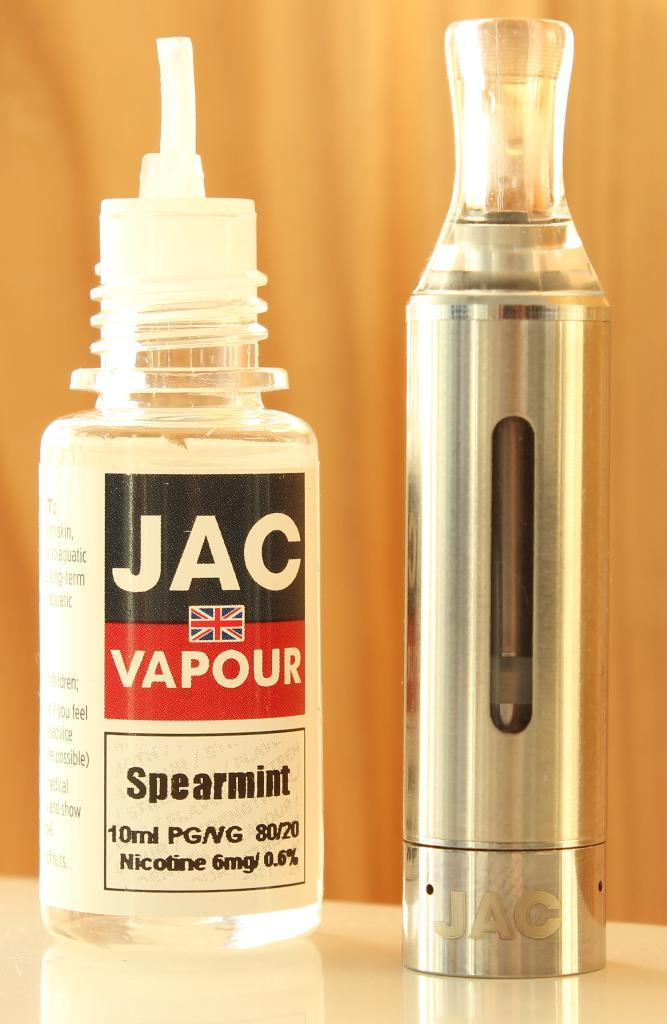<image>
Summarize the visual content of the image. A JAC bottle next to a silver one on a table 